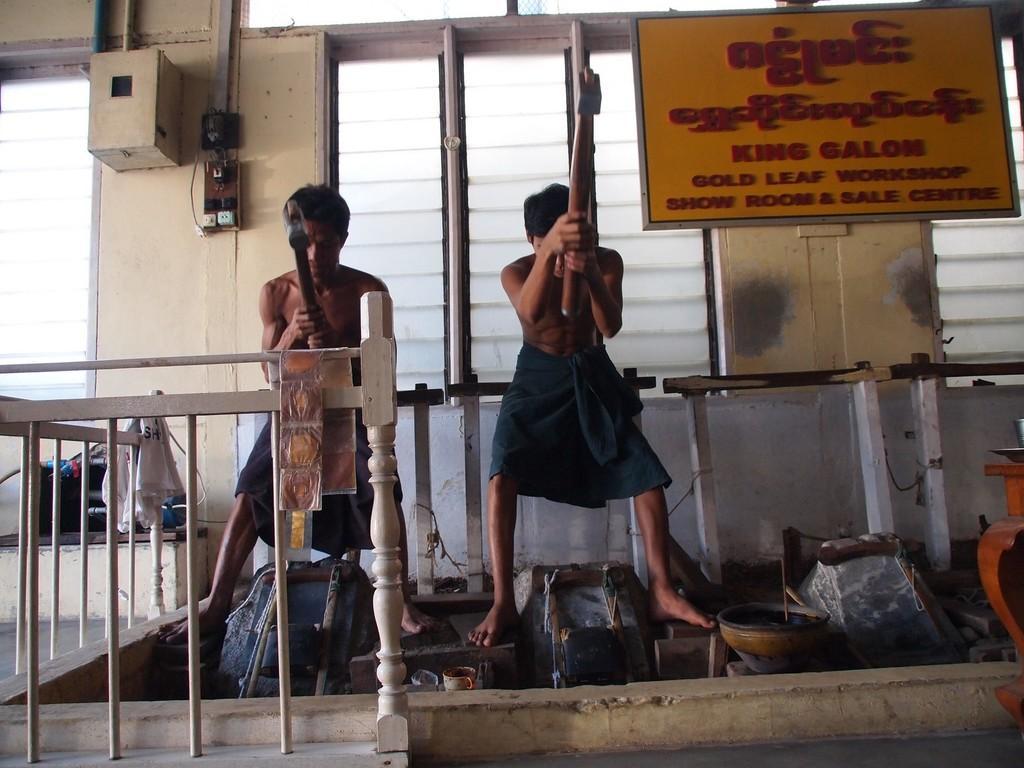Can you describe this image briefly? In the picture we can see two men are working in goldsmith shop and they are holding hammers and hitting something to shape and around them, we can see a railing and behind them, we can see a wall with a window and glass in it and beside it we can see a meter and some switches beside it. 